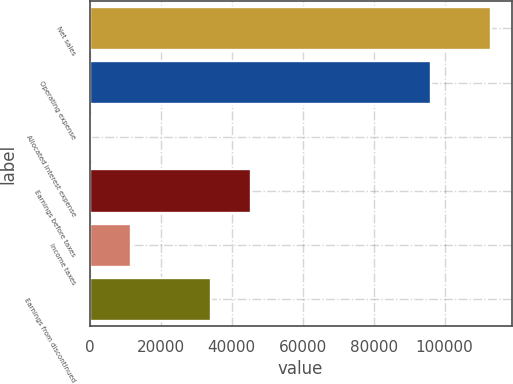Convert chart to OTSL. <chart><loc_0><loc_0><loc_500><loc_500><bar_chart><fcel>Net sales<fcel>Operating expense<fcel>Allocated interest expense<fcel>Earnings before taxes<fcel>Income taxes<fcel>Earnings from discontinued<nl><fcel>113206<fcel>96113<fcel>393<fcel>45518.2<fcel>11674.3<fcel>34236.9<nl></chart> 